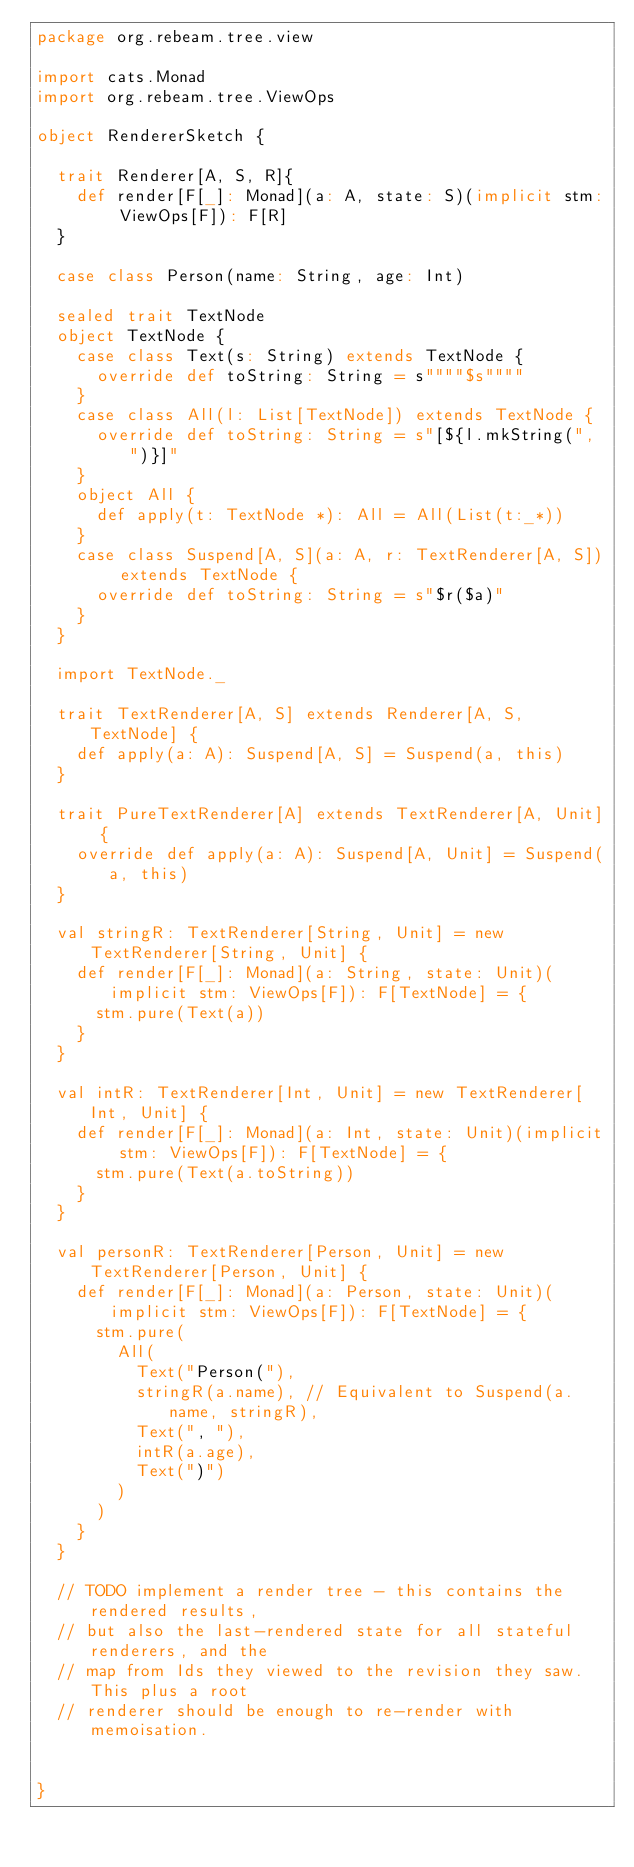<code> <loc_0><loc_0><loc_500><loc_500><_Scala_>package org.rebeam.tree.view

import cats.Monad
import org.rebeam.tree.ViewOps

object RendererSketch {

  trait Renderer[A, S, R]{
    def render[F[_]: Monad](a: A, state: S)(implicit stm: ViewOps[F]): F[R]
  }

  case class Person(name: String, age: Int)

  sealed trait TextNode
  object TextNode {
    case class Text(s: String) extends TextNode {
      override def toString: String = s""""$s""""
    }
    case class All(l: List[TextNode]) extends TextNode {
      override def toString: String = s"[${l.mkString(", ")}]"
    }
    object All {
      def apply(t: TextNode *): All = All(List(t:_*))
    }
    case class Suspend[A, S](a: A, r: TextRenderer[A, S]) extends TextNode {
      override def toString: String = s"$r($a)"
    }
  }

  import TextNode._

  trait TextRenderer[A, S] extends Renderer[A, S, TextNode] {
    def apply(a: A): Suspend[A, S] = Suspend(a, this)
  }

  trait PureTextRenderer[A] extends TextRenderer[A, Unit] {
    override def apply(a: A): Suspend[A, Unit] = Suspend(a, this)
  }

  val stringR: TextRenderer[String, Unit] = new TextRenderer[String, Unit] {
    def render[F[_]: Monad](a: String, state: Unit)(implicit stm: ViewOps[F]): F[TextNode] = {
      stm.pure(Text(a))
    }
  }

  val intR: TextRenderer[Int, Unit] = new TextRenderer[Int, Unit] {
    def render[F[_]: Monad](a: Int, state: Unit)(implicit stm: ViewOps[F]): F[TextNode] = {
      stm.pure(Text(a.toString))
    }
  }

  val personR: TextRenderer[Person, Unit] = new TextRenderer[Person, Unit] {
    def render[F[_]: Monad](a: Person, state: Unit)(implicit stm: ViewOps[F]): F[TextNode] = {
      stm.pure(
        All(
          Text("Person("),
          stringR(a.name), // Equivalent to Suspend(a.name, stringR),
          Text(", "),
          intR(a.age),
          Text(")")
        )
      )
    }
  }

  // TODO implement a render tree - this contains the rendered results,
  // but also the last-rendered state for all stateful renderers, and the
  // map from Ids they viewed to the revision they saw. This plus a root
  // renderer should be enough to re-render with memoisation.


}</code> 